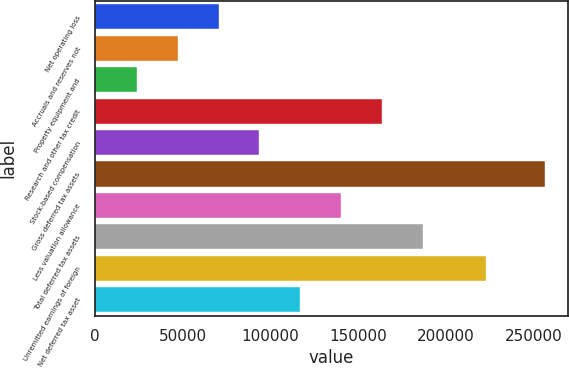<chart> <loc_0><loc_0><loc_500><loc_500><bar_chart><fcel>Net operating loss<fcel>Accruals and reserves not<fcel>Property equipment and<fcel>Research and other tax credit<fcel>Stock-based compensation<fcel>Gross deferred tax assets<fcel>Less valuation allowance<fcel>Total deferred tax assets<fcel>Unremitted earnings of foreign<fcel>Net deferred tax asset<nl><fcel>70516.6<fcel>47225.8<fcel>23935<fcel>163680<fcel>93807.4<fcel>256843<fcel>140389<fcel>186971<fcel>223223<fcel>117098<nl></chart> 